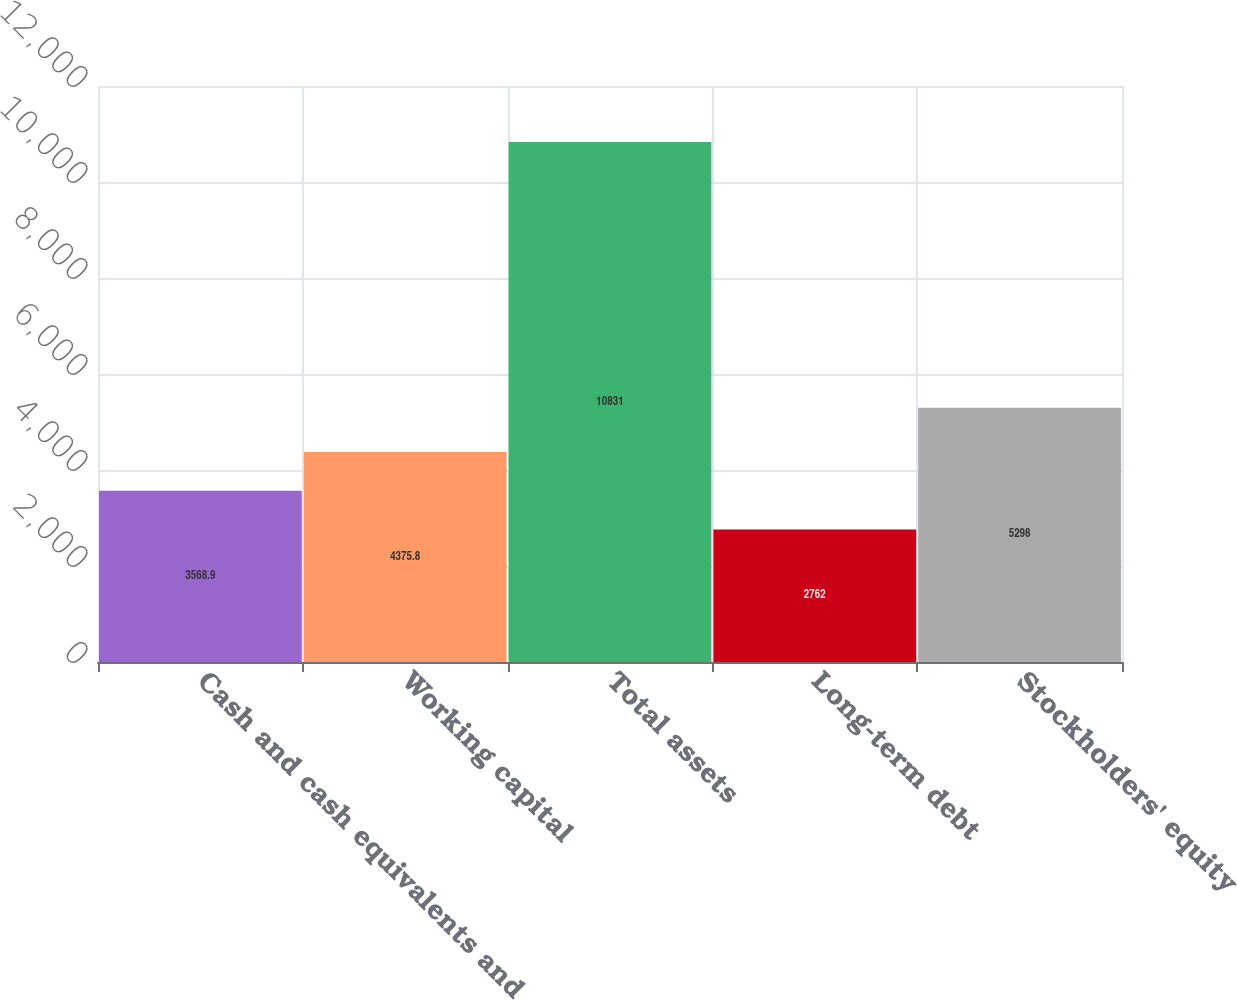Convert chart. <chart><loc_0><loc_0><loc_500><loc_500><bar_chart><fcel>Cash and cash equivalents and<fcel>Working capital<fcel>Total assets<fcel>Long-term debt<fcel>Stockholders' equity<nl><fcel>3568.9<fcel>4375.8<fcel>10831<fcel>2762<fcel>5298<nl></chart> 